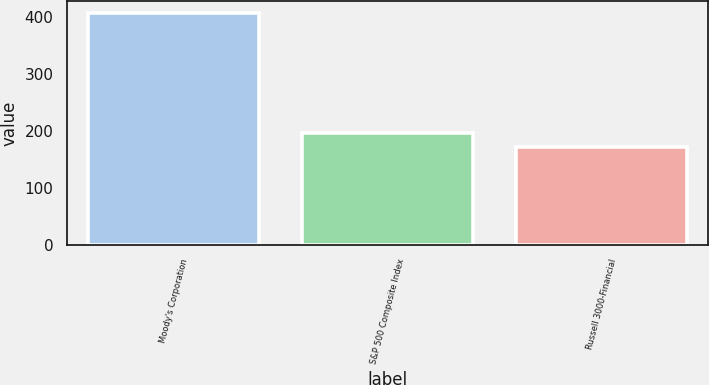Convert chart. <chart><loc_0><loc_0><loc_500><loc_500><bar_chart><fcel>Moody's Corporation<fcel>S&P 500 Composite Index<fcel>Russell 3000-Financial<nl><fcel>406.48<fcel>195.31<fcel>171.85<nl></chart> 